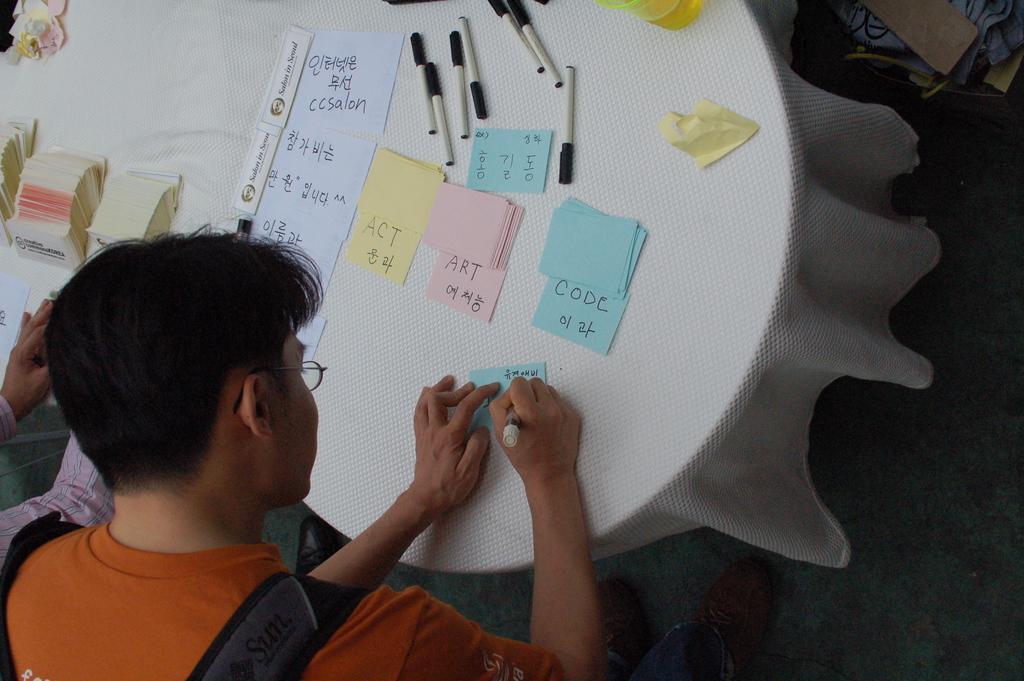Can you describe this image briefly? In this image there is a table and we can see papers, pens and a glass placed on the table. There are two people standing and writing on the paper which is placed on the table. 